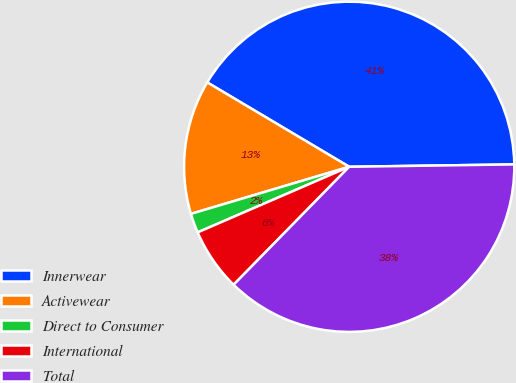<chart> <loc_0><loc_0><loc_500><loc_500><pie_chart><fcel>Innerwear<fcel>Activewear<fcel>Direct to Consumer<fcel>International<fcel>Total<nl><fcel>41.24%<fcel>13.14%<fcel>1.9%<fcel>6.16%<fcel>37.57%<nl></chart> 